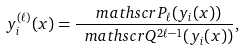<formula> <loc_0><loc_0><loc_500><loc_500>y _ { i } ^ { ( \ell ) } ( x ) = \frac { \ m a t h s c r { P } _ { \ell } ( y _ { i } ( x ) ) } { \ m a t h s c r { Q } ^ { 2 { \ell } - 1 } ( y _ { i } ( x ) ) } ,</formula> 